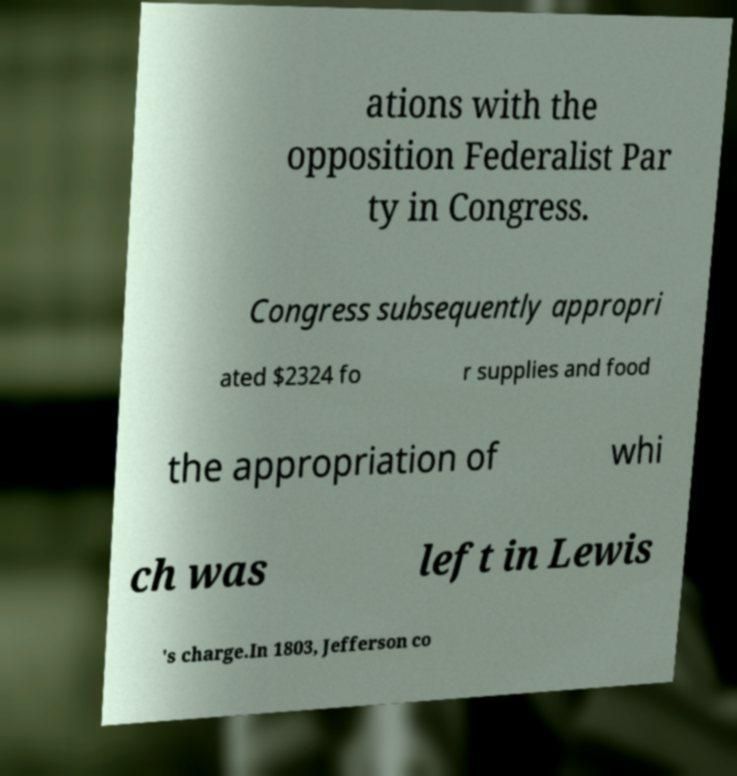Can you read and provide the text displayed in the image?This photo seems to have some interesting text. Can you extract and type it out for me? ations with the opposition Federalist Par ty in Congress. Congress subsequently appropri ated $2324 fo r supplies and food the appropriation of whi ch was left in Lewis 's charge.In 1803, Jefferson co 